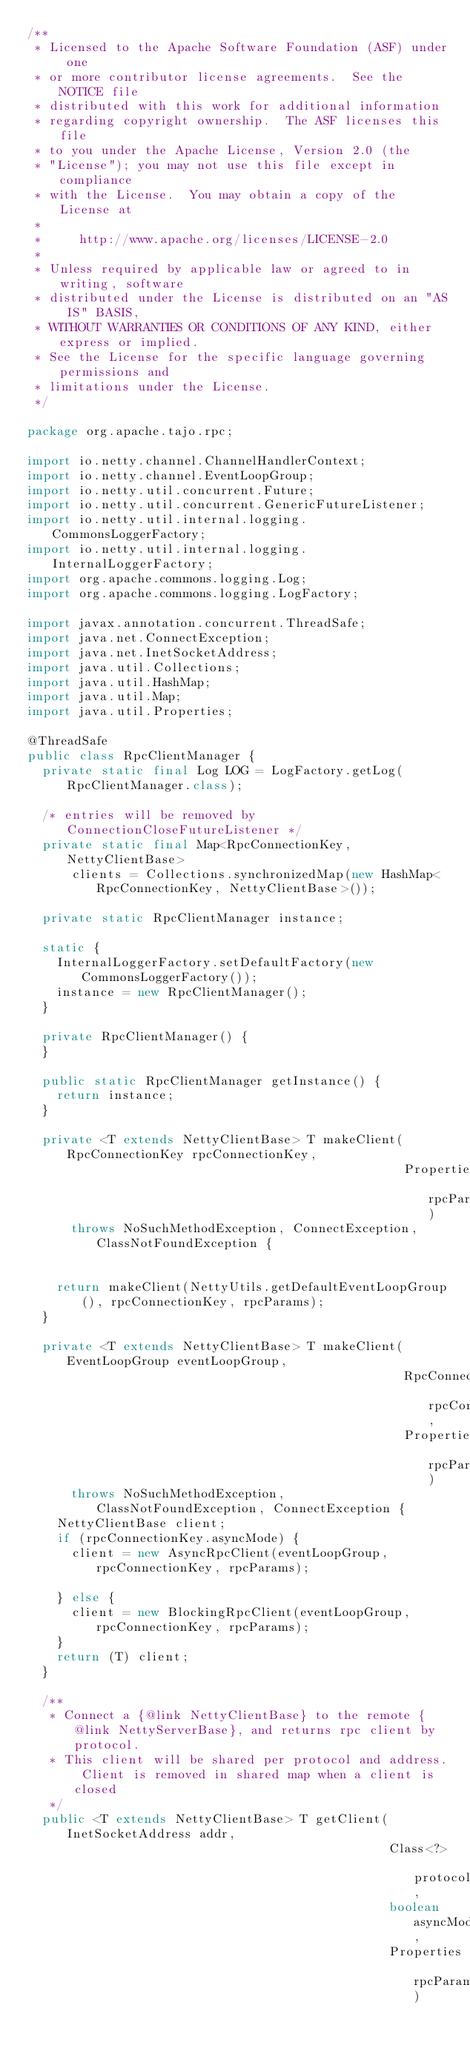<code> <loc_0><loc_0><loc_500><loc_500><_Java_>/**
 * Licensed to the Apache Software Foundation (ASF) under one
 * or more contributor license agreements.  See the NOTICE file
 * distributed with this work for additional information
 * regarding copyright ownership.  The ASF licenses this file
 * to you under the Apache License, Version 2.0 (the
 * "License"); you may not use this file except in compliance
 * with the License.  You may obtain a copy of the License at
 *
 *     http://www.apache.org/licenses/LICENSE-2.0
 *
 * Unless required by applicable law or agreed to in writing, software
 * distributed under the License is distributed on an "AS IS" BASIS,
 * WITHOUT WARRANTIES OR CONDITIONS OF ANY KIND, either express or implied.
 * See the License for the specific language governing permissions and
 * limitations under the License.
 */

package org.apache.tajo.rpc;

import io.netty.channel.ChannelHandlerContext;
import io.netty.channel.EventLoopGroup;
import io.netty.util.concurrent.Future;
import io.netty.util.concurrent.GenericFutureListener;
import io.netty.util.internal.logging.CommonsLoggerFactory;
import io.netty.util.internal.logging.InternalLoggerFactory;
import org.apache.commons.logging.Log;
import org.apache.commons.logging.LogFactory;

import javax.annotation.concurrent.ThreadSafe;
import java.net.ConnectException;
import java.net.InetSocketAddress;
import java.util.Collections;
import java.util.HashMap;
import java.util.Map;
import java.util.Properties;

@ThreadSafe
public class RpcClientManager {
  private static final Log LOG = LogFactory.getLog(RpcClientManager.class);

  /* entries will be removed by ConnectionCloseFutureListener */
  private static final Map<RpcConnectionKey, NettyClientBase>
      clients = Collections.synchronizedMap(new HashMap<RpcConnectionKey, NettyClientBase>());

  private static RpcClientManager instance;

  static {
    InternalLoggerFactory.setDefaultFactory(new CommonsLoggerFactory());
    instance = new RpcClientManager();
  }

  private RpcClientManager() {
  }

  public static RpcClientManager getInstance() {
    return instance;
  }

  private <T extends NettyClientBase> T makeClient(RpcConnectionKey rpcConnectionKey,
                                                   Properties rpcParams)
      throws NoSuchMethodException, ConnectException, ClassNotFoundException {


    return makeClient(NettyUtils.getDefaultEventLoopGroup(), rpcConnectionKey, rpcParams);
  }

  private <T extends NettyClientBase> T makeClient(EventLoopGroup eventLoopGroup,
                                                   RpcConnectionKey rpcConnectionKey,
                                                   Properties rpcParams)
      throws NoSuchMethodException, ClassNotFoundException, ConnectException {
    NettyClientBase client;
    if (rpcConnectionKey.asyncMode) {
      client = new AsyncRpcClient(eventLoopGroup, rpcConnectionKey, rpcParams);

    } else {
      client = new BlockingRpcClient(eventLoopGroup, rpcConnectionKey, rpcParams);
    }
    return (T) client;
  }

  /**
   * Connect a {@link NettyClientBase} to the remote {@link NettyServerBase}, and returns rpc client by protocol.
   * This client will be shared per protocol and address. Client is removed in shared map when a client is closed
   */
  public <T extends NettyClientBase> T getClient(InetSocketAddress addr,
                                                 Class<?> protocolClass,
                                                 boolean asyncMode,
                                                 Properties rpcParams)</code> 